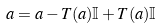Convert formula to latex. <formula><loc_0><loc_0><loc_500><loc_500>a = a - T ( a ) \mathbb { I } + T ( a ) \mathbb { I }</formula> 